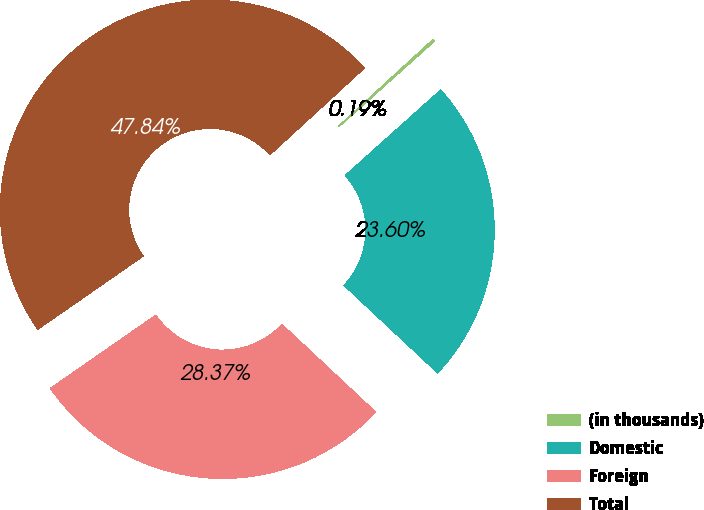<chart> <loc_0><loc_0><loc_500><loc_500><pie_chart><fcel>(in thousands)<fcel>Domestic<fcel>Foreign<fcel>Total<nl><fcel>0.19%<fcel>23.6%<fcel>28.37%<fcel>47.84%<nl></chart> 